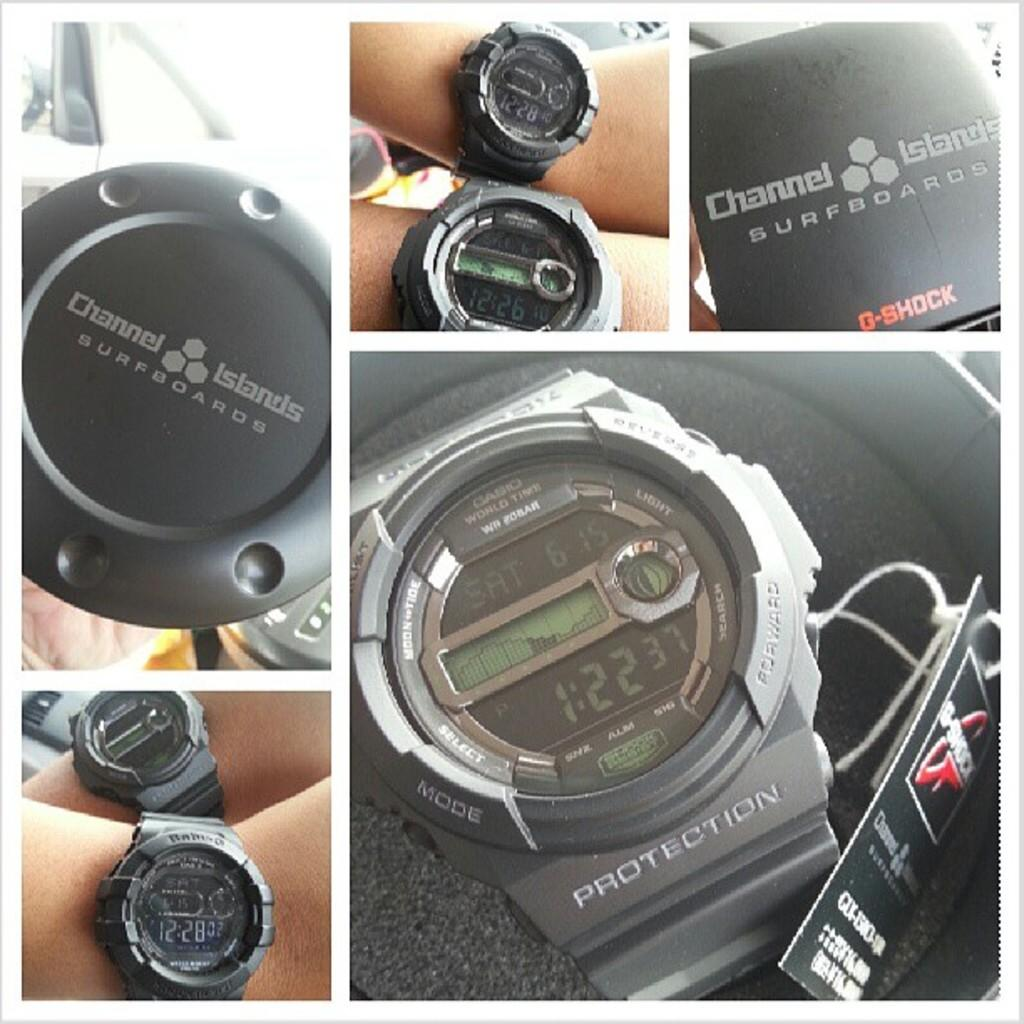<image>
Present a compact description of the photo's key features. A silver watch says "PROTECTION" under the face. 